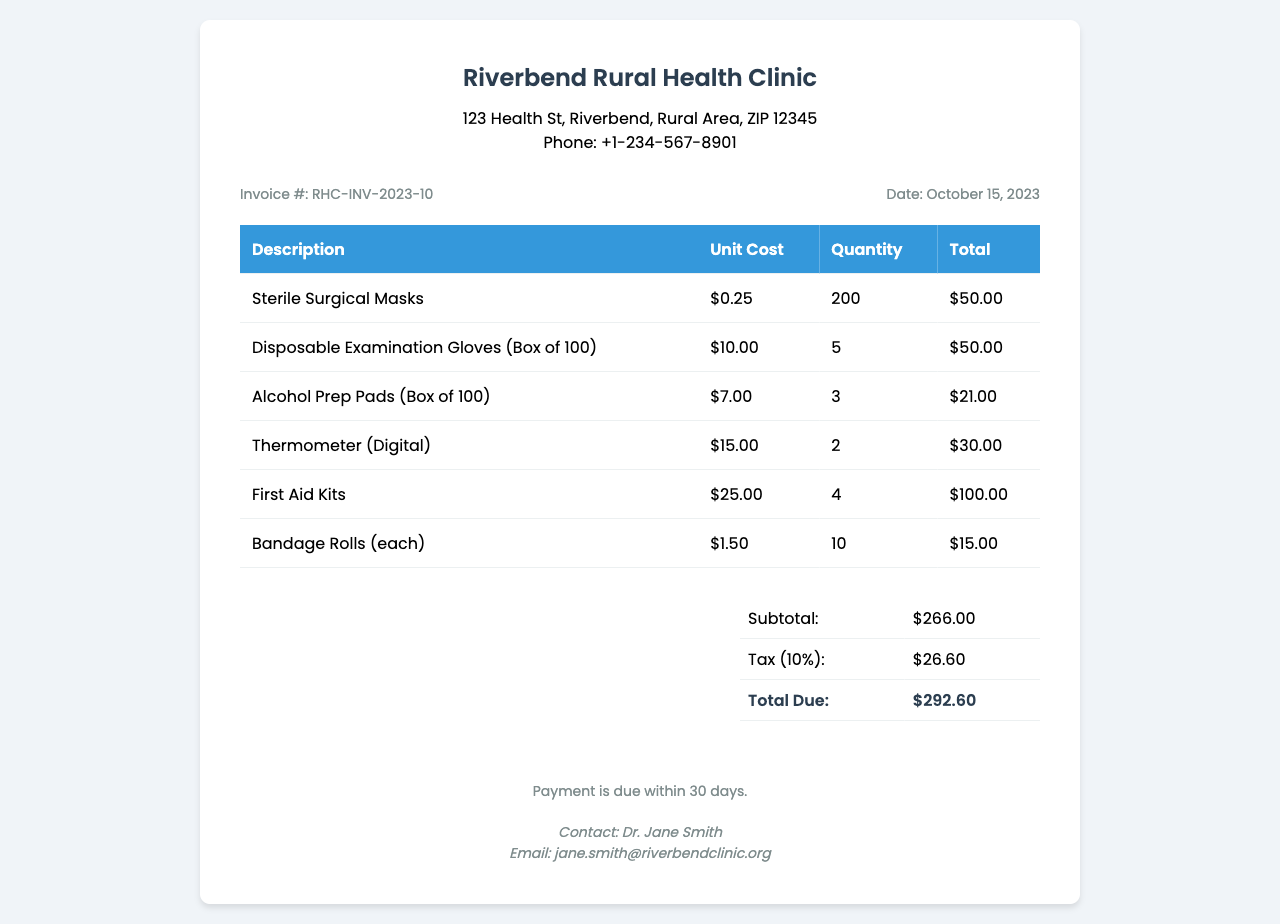What is the invoice number? The invoice number is clearly stated in the document details as "RHC-INV-2023-10."
Answer: RHC-INV-2023-10 What is the date of the invoice? The date is provided in the invoice details section as "October 15, 2023."
Answer: October 15, 2023 How many Sterile Surgical Masks were purchased? The quantity for Sterile Surgical Masks is listed as "200" in the table of items.
Answer: 200 What is the total cost of Disposable Examination Gloves? The total cost is specified in the table as "$50.00."
Answer: $50.00 What is the subtotal amount before tax? The subtotal is mentioned in the summary section as "$266.00."
Answer: $266.00 What is the tax rate applied in this invoice? The document states a tax of "10%" applied to the subtotal.
Answer: 10% What is the total amount due? The total amount due is indicated in the summary as "$292.60."
Answer: $292.60 Who is the contact person for this invoice? The contact person is listed as "Dr. Jane Smith" in the footer.
Answer: Dr. Jane Smith How many First Aid Kits were ordered? The quantity of First Aid Kits is mentioned as "4" in the items table.
Answer: 4 What is the price of a digital thermometer? The price for a digital thermometer is stated as "$15.00."
Answer: $15.00 